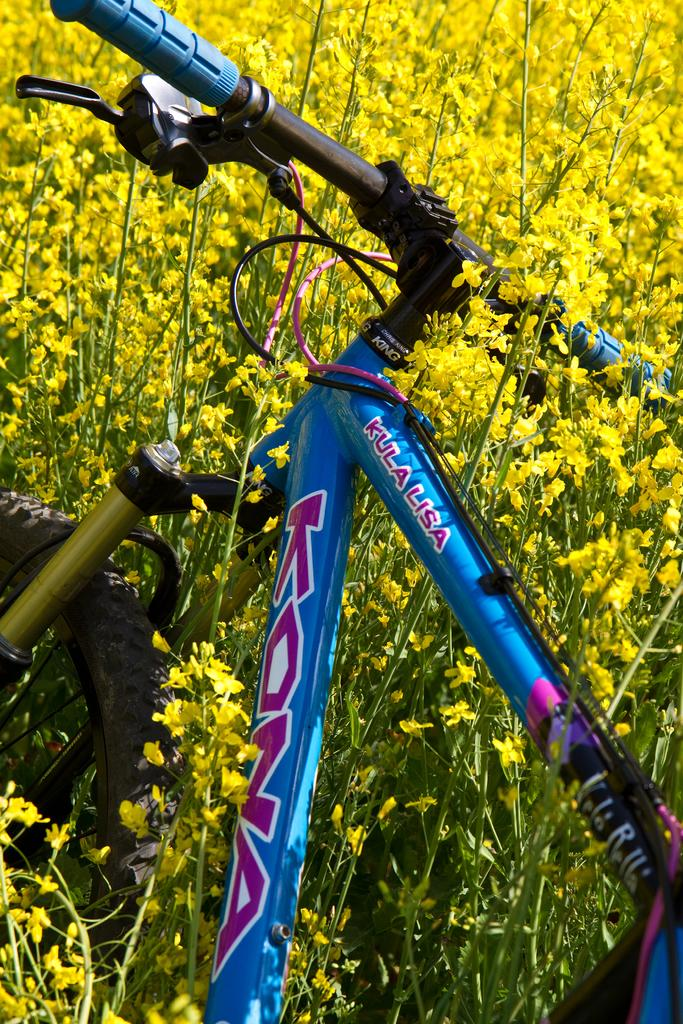What type of vegetation can be seen in the background of the image? There are yellow flowers and plants in the background of the image. What object is present in the image besides the vegetation? There is a bicycle in the image. What type of school can be seen in the image? There is no school present in the image; it features yellow flowers and plants in the background and a bicycle. What type of motion is the quarter performing in the image? There is no quarter present in the image, and therefore no motion can be observed. 